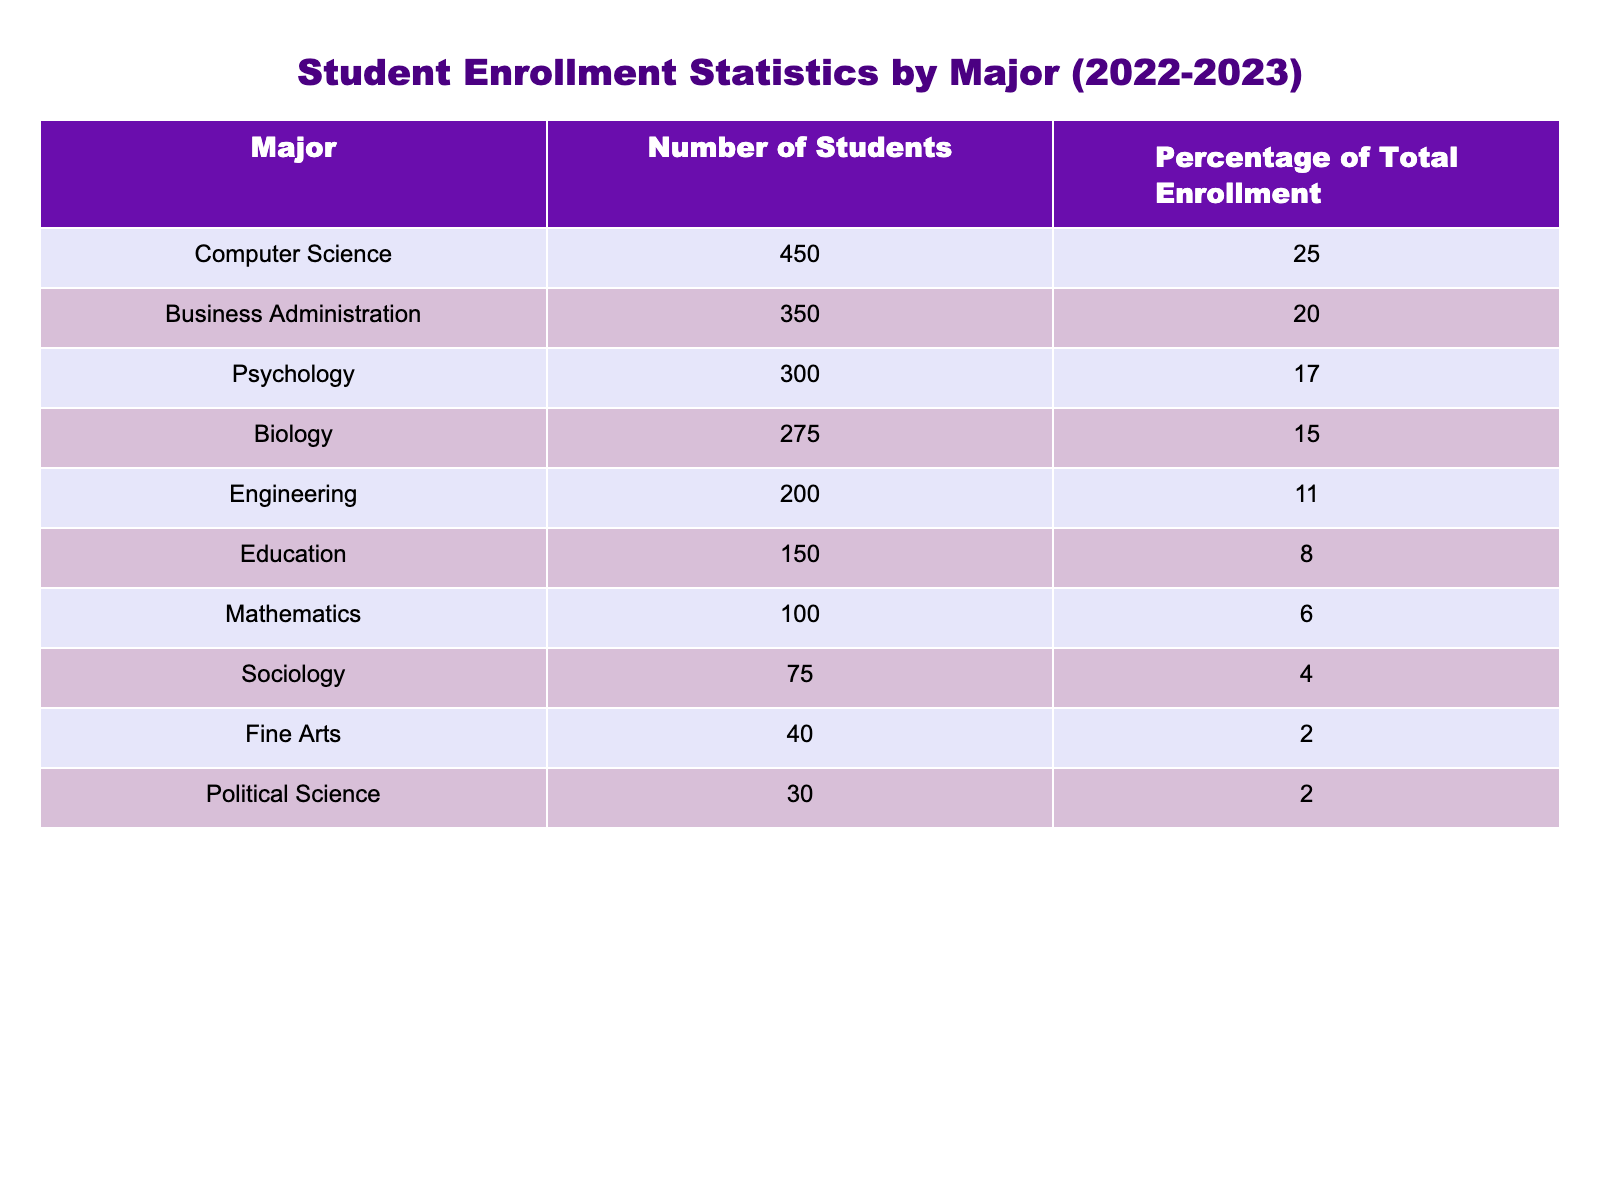What is the total number of students enrolled in Computer Science? The table shows that the number of students in Computer Science is specifically listed as 450 in the 'Number of Students' column.
Answer: 450 What percentage of total enrollment does Business Administration represent? The table confirms that Business Administration has a percentage of 20% as indicated in the 'Percentage of Total Enrollment' column.
Answer: 20% How many more students are enrolled in Psychology than in Education? To find the difference, we subtract the number of students in Education (150) from the number of students in Psychology (300). This gives us 300 - 150 = 150 more students.
Answer: 150 What is the total number of students enrolled in Mathematics and Sociology combined? We add the number of students in Mathematics (100) and Sociology (75). Therefore, the total number of students is 100 + 75 = 175.
Answer: 175 Is the enrollment in Fine Arts greater than in Political Science? The table shows Fine Arts has 40 students and Political Science has 30 students. Since 40 is greater than 30, we can conclude this is true.
Answer: Yes What is the average number of students across all the majors listed? To find the average, we first sum up all the students: 450 + 350 + 300 + 275 + 200 + 150 + 100 + 75 + 40 + 30 = 1970. There are 10 majors, so we divide 1970 by 10, giving us an average of 197.
Answer: 197 Which major has the lowest enrollment, and how many students are in that major? By examining the 'Number of Students' column, we can see that Political Science has the lowest enrollment with 30 students.
Answer: Political Science, 30 How many students are in majors that represent less than 10% of total enrollment? We filter for majors that have a percentage of total enrollment below 10%. They are Education (8%), Mathematics (6%), Sociology (4%), Fine Arts (2%), and Political Science (2%). Their student counts are 150 + 100 + 75 + 40 + 30 = 395.
Answer: 395 What percentage of the total enrollment is made up by the top three majors (Computer Science, Business Administration, and Psychology)? First, we find the total enrollment of the top three majors: 450 (Computer Science) + 350 (Business Administration) + 300 (Psychology) = 1100. Total enrollment from the table is 1800 (sum of all students). Thus, the percentage is (1100/1800) * 100 = 61.1%.
Answer: 61.1% 